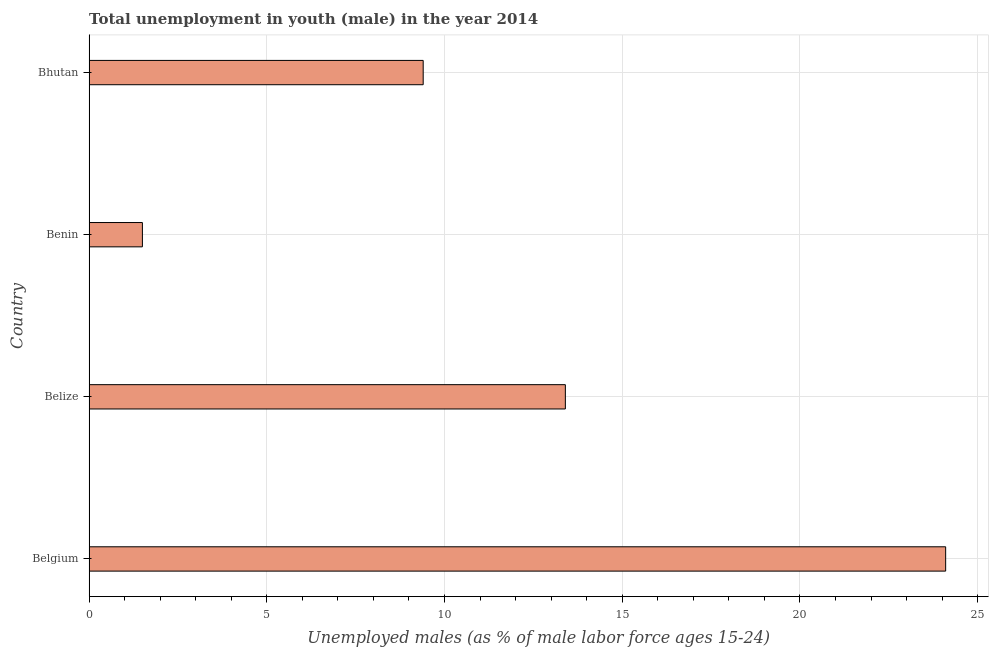What is the title of the graph?
Make the answer very short. Total unemployment in youth (male) in the year 2014. What is the label or title of the X-axis?
Ensure brevity in your answer.  Unemployed males (as % of male labor force ages 15-24). What is the unemployed male youth population in Belize?
Provide a short and direct response. 13.4. Across all countries, what is the maximum unemployed male youth population?
Provide a succinct answer. 24.1. In which country was the unemployed male youth population minimum?
Your answer should be very brief. Benin. What is the sum of the unemployed male youth population?
Give a very brief answer. 48.4. What is the median unemployed male youth population?
Offer a very short reply. 11.4. What is the ratio of the unemployed male youth population in Belize to that in Bhutan?
Your response must be concise. 1.43. Is the unemployed male youth population in Benin less than that in Bhutan?
Keep it short and to the point. Yes. What is the difference between the highest and the second highest unemployed male youth population?
Keep it short and to the point. 10.7. Is the sum of the unemployed male youth population in Belgium and Benin greater than the maximum unemployed male youth population across all countries?
Keep it short and to the point. Yes. What is the difference between the highest and the lowest unemployed male youth population?
Keep it short and to the point. 22.6. In how many countries, is the unemployed male youth population greater than the average unemployed male youth population taken over all countries?
Provide a short and direct response. 2. Are all the bars in the graph horizontal?
Give a very brief answer. Yes. What is the difference between two consecutive major ticks on the X-axis?
Your response must be concise. 5. Are the values on the major ticks of X-axis written in scientific E-notation?
Make the answer very short. No. What is the Unemployed males (as % of male labor force ages 15-24) of Belgium?
Provide a short and direct response. 24.1. What is the Unemployed males (as % of male labor force ages 15-24) of Belize?
Offer a terse response. 13.4. What is the Unemployed males (as % of male labor force ages 15-24) of Benin?
Ensure brevity in your answer.  1.5. What is the Unemployed males (as % of male labor force ages 15-24) in Bhutan?
Ensure brevity in your answer.  9.4. What is the difference between the Unemployed males (as % of male labor force ages 15-24) in Belgium and Benin?
Your answer should be very brief. 22.6. What is the difference between the Unemployed males (as % of male labor force ages 15-24) in Belgium and Bhutan?
Offer a very short reply. 14.7. What is the ratio of the Unemployed males (as % of male labor force ages 15-24) in Belgium to that in Belize?
Provide a succinct answer. 1.8. What is the ratio of the Unemployed males (as % of male labor force ages 15-24) in Belgium to that in Benin?
Offer a very short reply. 16.07. What is the ratio of the Unemployed males (as % of male labor force ages 15-24) in Belgium to that in Bhutan?
Your answer should be compact. 2.56. What is the ratio of the Unemployed males (as % of male labor force ages 15-24) in Belize to that in Benin?
Provide a succinct answer. 8.93. What is the ratio of the Unemployed males (as % of male labor force ages 15-24) in Belize to that in Bhutan?
Provide a short and direct response. 1.43. What is the ratio of the Unemployed males (as % of male labor force ages 15-24) in Benin to that in Bhutan?
Offer a terse response. 0.16. 